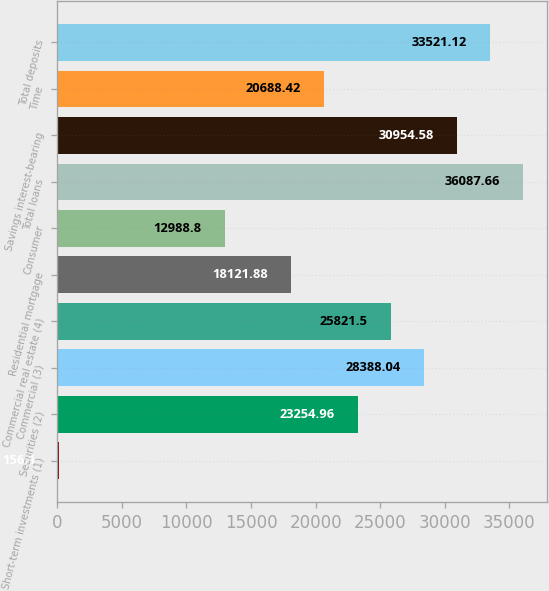Convert chart. <chart><loc_0><loc_0><loc_500><loc_500><bar_chart><fcel>Short-term investments (1)<fcel>Securities (2)<fcel>Commercial (3)<fcel>Commercial real estate (4)<fcel>Residential mortgage<fcel>Consumer<fcel>Total loans<fcel>Savings interest-bearing<fcel>Time<fcel>Total deposits<nl><fcel>156.1<fcel>23255<fcel>28388<fcel>25821.5<fcel>18121.9<fcel>12988.8<fcel>36087.7<fcel>30954.6<fcel>20688.4<fcel>33521.1<nl></chart> 